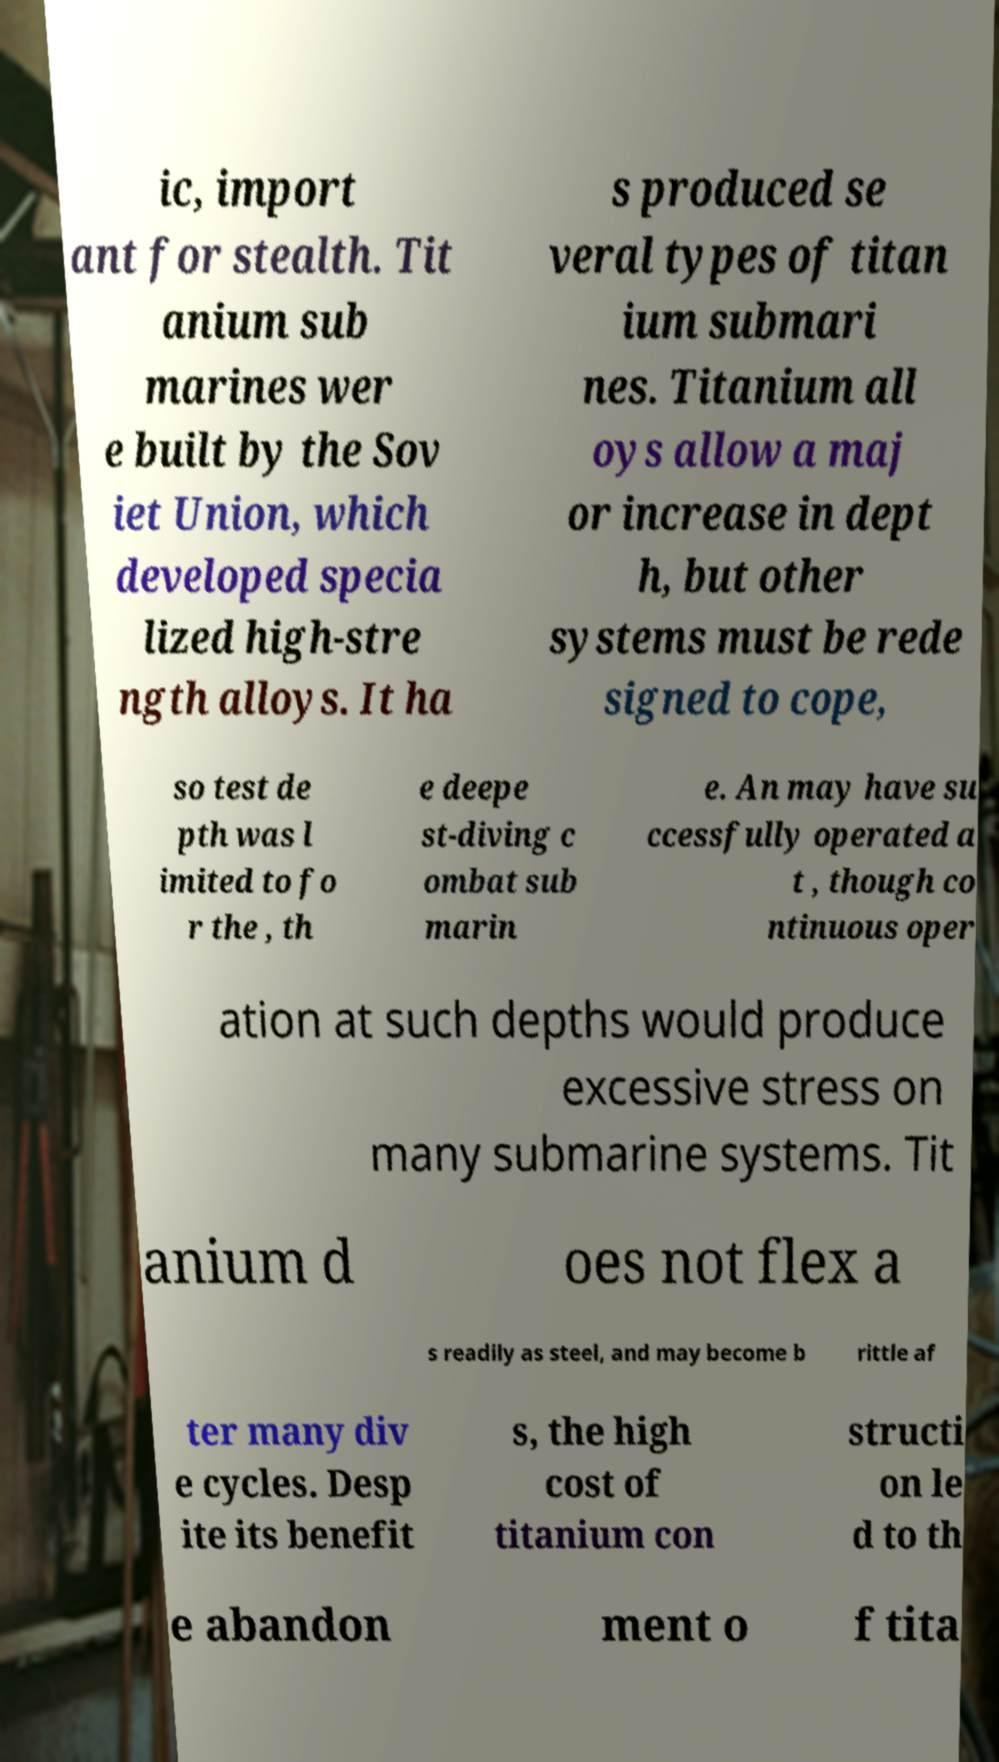Can you read and provide the text displayed in the image?This photo seems to have some interesting text. Can you extract and type it out for me? ic, import ant for stealth. Tit anium sub marines wer e built by the Sov iet Union, which developed specia lized high-stre ngth alloys. It ha s produced se veral types of titan ium submari nes. Titanium all oys allow a maj or increase in dept h, but other systems must be rede signed to cope, so test de pth was l imited to fo r the , th e deepe st-diving c ombat sub marin e. An may have su ccessfully operated a t , though co ntinuous oper ation at such depths would produce excessive stress on many submarine systems. Tit anium d oes not flex a s readily as steel, and may become b rittle af ter many div e cycles. Desp ite its benefit s, the high cost of titanium con structi on le d to th e abandon ment o f tita 